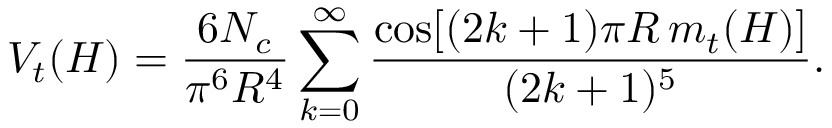Convert formula to latex. <formula><loc_0><loc_0><loc_500><loc_500>V _ { t } ( H ) = { \frac { 6 N _ { c } } { \pi ^ { 6 } R ^ { 4 } } } \sum _ { k = 0 } ^ { \infty } { \frac { \cos [ ( 2 k + 1 ) \pi R \, m _ { t } ( H ) ] } { ( 2 k + 1 ) ^ { 5 } } } .</formula> 